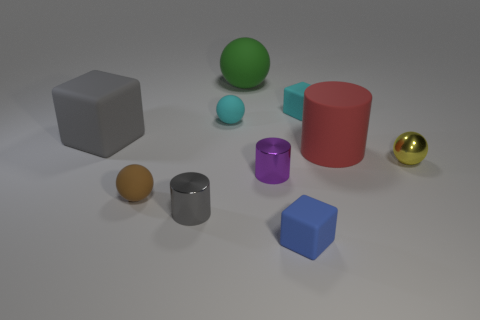Subtract all spheres. How many objects are left? 6 Subtract all big brown matte balls. Subtract all metal objects. How many objects are left? 7 Add 5 small spheres. How many small spheres are left? 8 Add 5 gray cylinders. How many gray cylinders exist? 6 Subtract 0 red spheres. How many objects are left? 10 